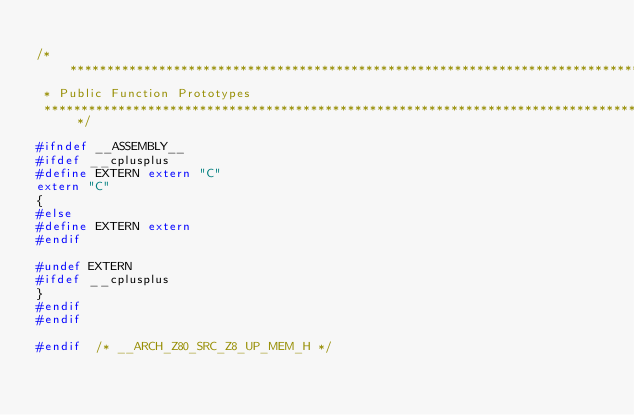Convert code to text. <code><loc_0><loc_0><loc_500><loc_500><_C_>
/************************************************************************************
 * Public Function Prototypes
 ************************************************************************************/

#ifndef __ASSEMBLY__
#ifdef __cplusplus
#define EXTERN extern "C"
extern "C"
{
#else
#define EXTERN extern
#endif

#undef EXTERN
#ifdef __cplusplus
}
#endif
#endif

#endif  /* __ARCH_Z80_SRC_Z8_UP_MEM_H */
</code> 